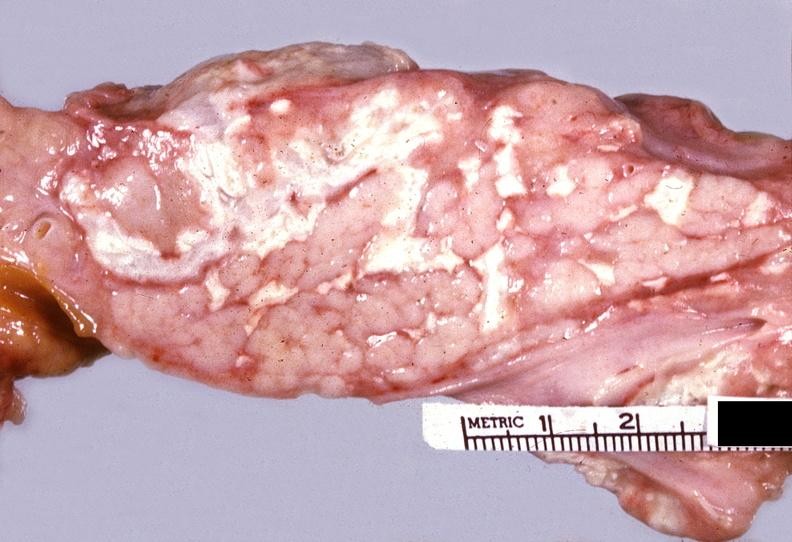what does this image show?
Answer the question using a single word or phrase. Acute pancreatitis 